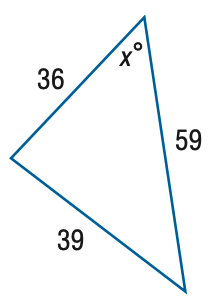Question: Find x. Round the angle measure to the nearest degree.
Choices:
A. 30
B. 35
C. 40
D. 45
Answer with the letter. Answer: C 